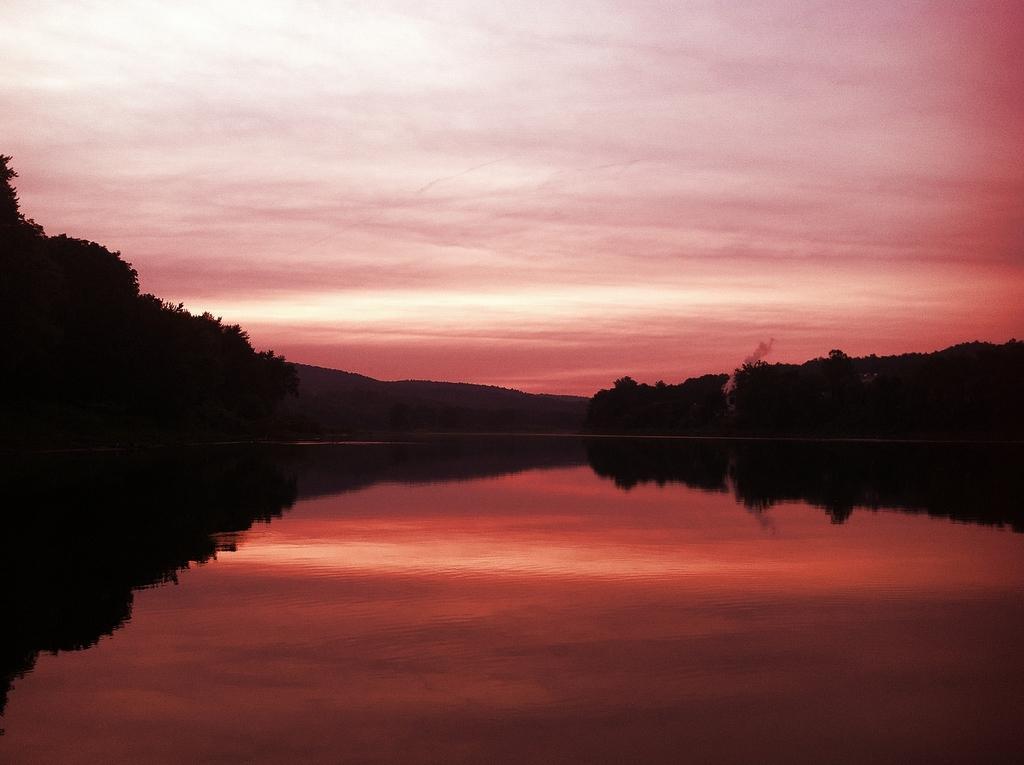Describe this image in one or two sentences. In this image in the center there is water and there are trees and the sky is cloudy. 